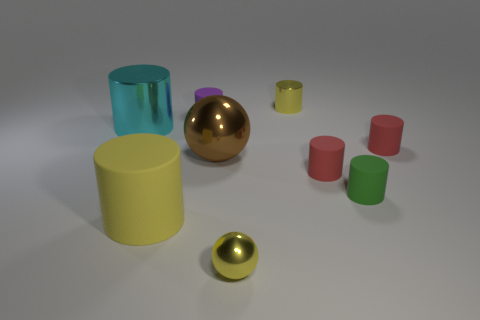Add 1 cyan things. How many objects exist? 10 Subtract all big cyan cylinders. How many cylinders are left? 6 Subtract all gray blocks. How many red cylinders are left? 2 Subtract all yellow spheres. How many spheres are left? 1 Subtract all spheres. How many objects are left? 7 Subtract all large metal objects. Subtract all brown spheres. How many objects are left? 6 Add 2 tiny cylinders. How many tiny cylinders are left? 7 Add 4 cyan matte objects. How many cyan matte objects exist? 4 Subtract 1 green cylinders. How many objects are left? 8 Subtract 4 cylinders. How many cylinders are left? 3 